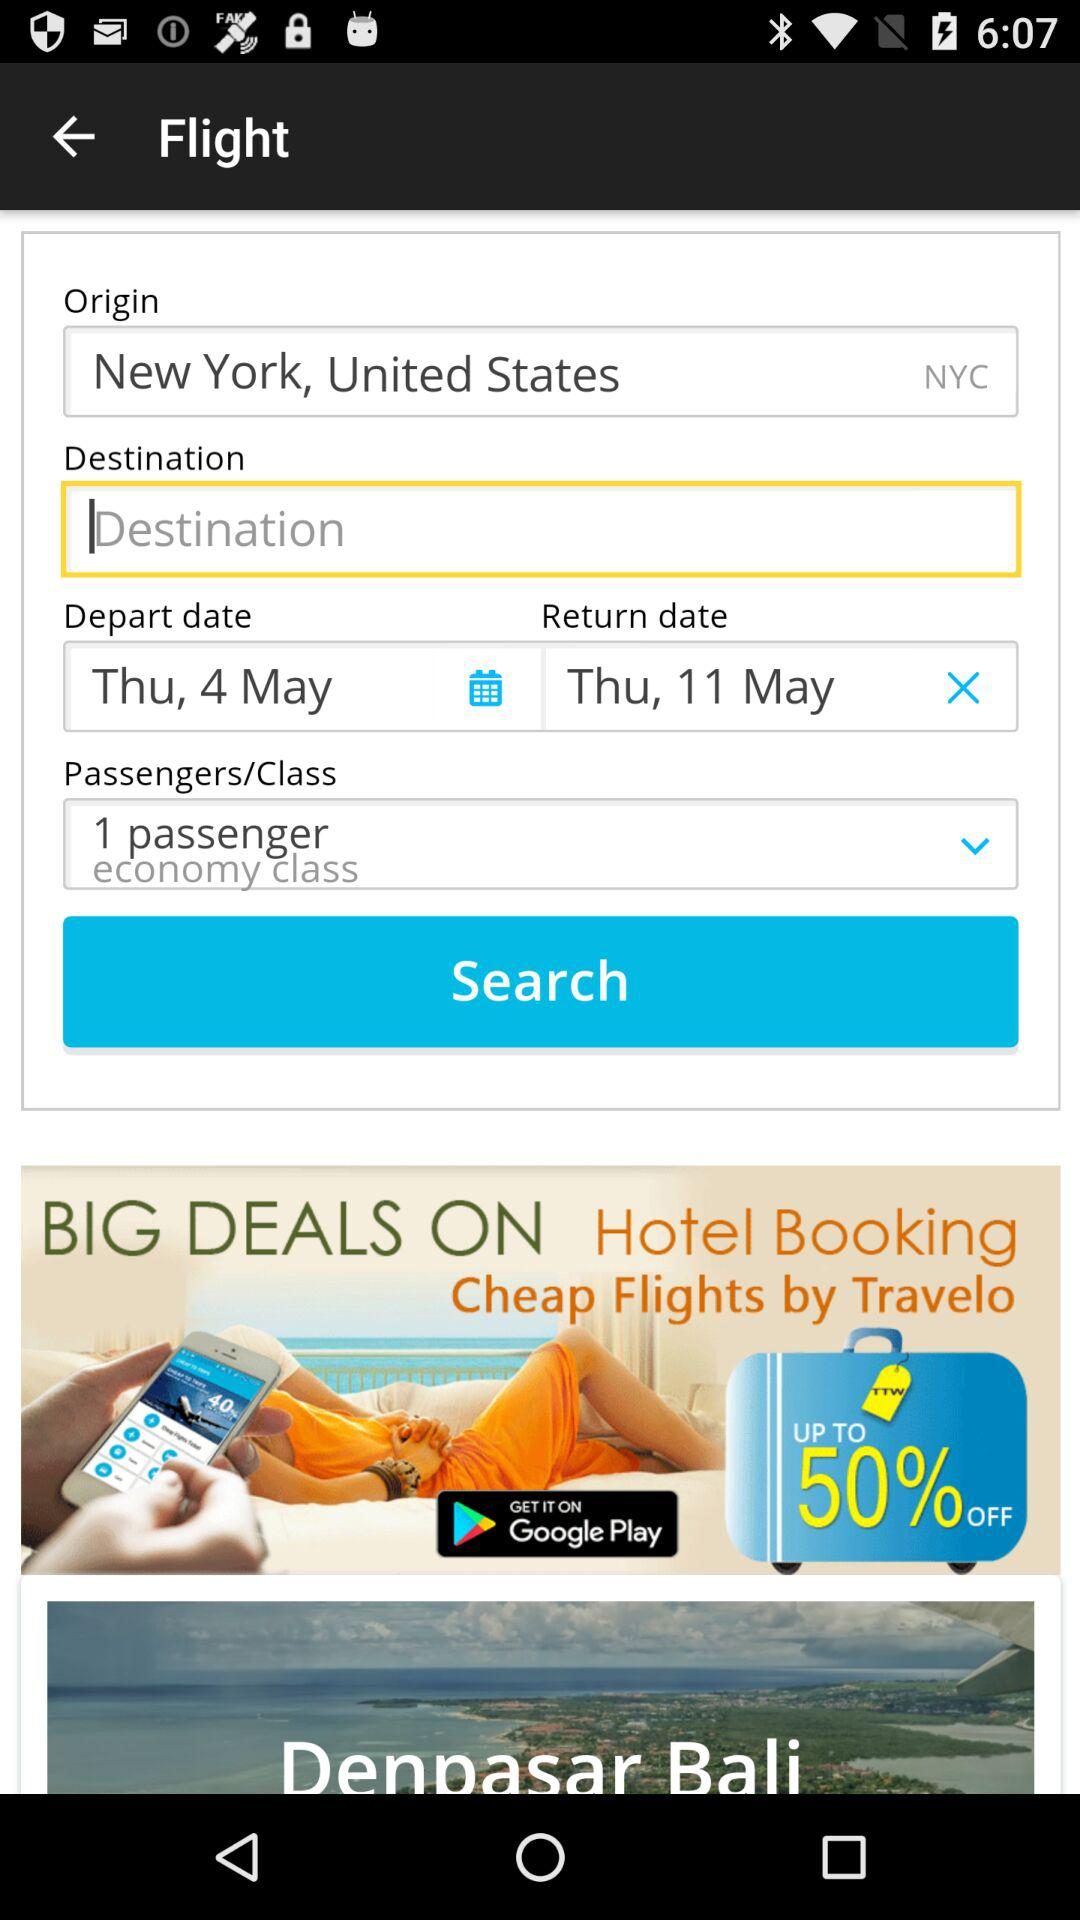What is the destination city referred to in the booking? The destination city in the booking is listed as NYC. 